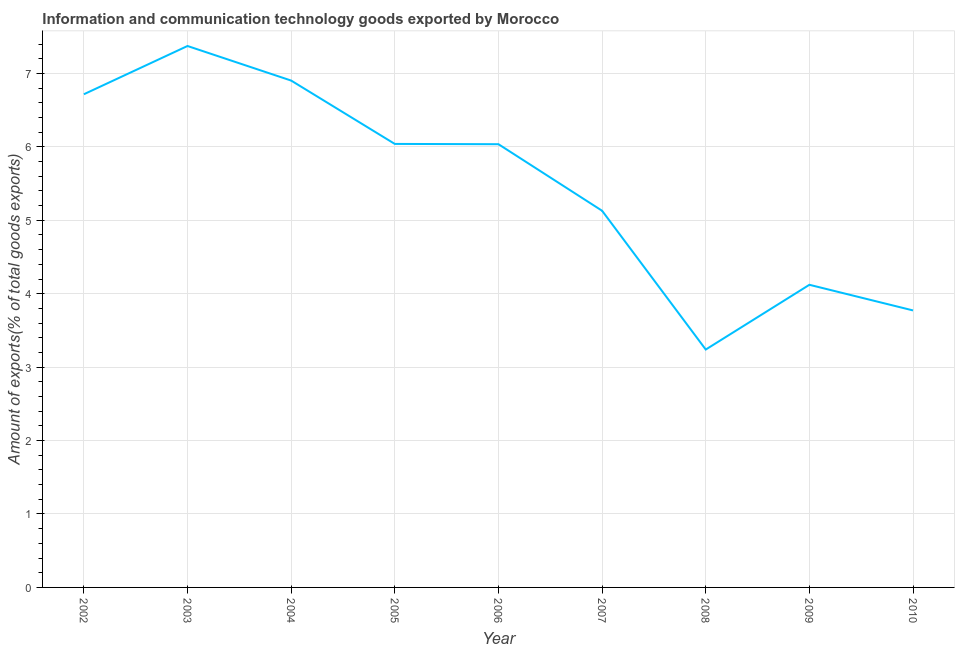What is the amount of ict goods exports in 2006?
Your answer should be compact. 6.04. Across all years, what is the maximum amount of ict goods exports?
Keep it short and to the point. 7.37. Across all years, what is the minimum amount of ict goods exports?
Give a very brief answer. 3.24. What is the sum of the amount of ict goods exports?
Make the answer very short. 49.33. What is the difference between the amount of ict goods exports in 2008 and 2010?
Ensure brevity in your answer.  -0.53. What is the average amount of ict goods exports per year?
Your answer should be very brief. 5.48. What is the median amount of ict goods exports?
Give a very brief answer. 6.04. Do a majority of the years between 2010 and 2006 (inclusive) have amount of ict goods exports greater than 1.6 %?
Your response must be concise. Yes. What is the ratio of the amount of ict goods exports in 2008 to that in 2009?
Your answer should be compact. 0.79. What is the difference between the highest and the second highest amount of ict goods exports?
Make the answer very short. 0.47. Is the sum of the amount of ict goods exports in 2002 and 2008 greater than the maximum amount of ict goods exports across all years?
Offer a terse response. Yes. What is the difference between the highest and the lowest amount of ict goods exports?
Make the answer very short. 4.13. In how many years, is the amount of ict goods exports greater than the average amount of ict goods exports taken over all years?
Keep it short and to the point. 5. Does the amount of ict goods exports monotonically increase over the years?
Offer a very short reply. No. How many years are there in the graph?
Keep it short and to the point. 9. What is the difference between two consecutive major ticks on the Y-axis?
Your response must be concise. 1. Are the values on the major ticks of Y-axis written in scientific E-notation?
Offer a very short reply. No. Does the graph contain grids?
Your answer should be very brief. Yes. What is the title of the graph?
Offer a terse response. Information and communication technology goods exported by Morocco. What is the label or title of the Y-axis?
Keep it short and to the point. Amount of exports(% of total goods exports). What is the Amount of exports(% of total goods exports) in 2002?
Your response must be concise. 6.72. What is the Amount of exports(% of total goods exports) of 2003?
Provide a short and direct response. 7.37. What is the Amount of exports(% of total goods exports) in 2004?
Keep it short and to the point. 6.9. What is the Amount of exports(% of total goods exports) in 2005?
Offer a very short reply. 6.04. What is the Amount of exports(% of total goods exports) of 2006?
Give a very brief answer. 6.04. What is the Amount of exports(% of total goods exports) of 2007?
Give a very brief answer. 5.13. What is the Amount of exports(% of total goods exports) in 2008?
Make the answer very short. 3.24. What is the Amount of exports(% of total goods exports) in 2009?
Provide a succinct answer. 4.12. What is the Amount of exports(% of total goods exports) of 2010?
Your response must be concise. 3.77. What is the difference between the Amount of exports(% of total goods exports) in 2002 and 2003?
Offer a very short reply. -0.66. What is the difference between the Amount of exports(% of total goods exports) in 2002 and 2004?
Your answer should be compact. -0.19. What is the difference between the Amount of exports(% of total goods exports) in 2002 and 2005?
Provide a succinct answer. 0.68. What is the difference between the Amount of exports(% of total goods exports) in 2002 and 2006?
Your answer should be compact. 0.68. What is the difference between the Amount of exports(% of total goods exports) in 2002 and 2007?
Offer a terse response. 1.59. What is the difference between the Amount of exports(% of total goods exports) in 2002 and 2008?
Your answer should be very brief. 3.48. What is the difference between the Amount of exports(% of total goods exports) in 2002 and 2009?
Give a very brief answer. 2.59. What is the difference between the Amount of exports(% of total goods exports) in 2002 and 2010?
Offer a terse response. 2.94. What is the difference between the Amount of exports(% of total goods exports) in 2003 and 2004?
Keep it short and to the point. 0.47. What is the difference between the Amount of exports(% of total goods exports) in 2003 and 2005?
Ensure brevity in your answer.  1.33. What is the difference between the Amount of exports(% of total goods exports) in 2003 and 2006?
Give a very brief answer. 1.34. What is the difference between the Amount of exports(% of total goods exports) in 2003 and 2007?
Keep it short and to the point. 2.24. What is the difference between the Amount of exports(% of total goods exports) in 2003 and 2008?
Offer a very short reply. 4.13. What is the difference between the Amount of exports(% of total goods exports) in 2003 and 2009?
Your answer should be compact. 3.25. What is the difference between the Amount of exports(% of total goods exports) in 2003 and 2010?
Provide a short and direct response. 3.6. What is the difference between the Amount of exports(% of total goods exports) in 2004 and 2005?
Keep it short and to the point. 0.86. What is the difference between the Amount of exports(% of total goods exports) in 2004 and 2006?
Keep it short and to the point. 0.87. What is the difference between the Amount of exports(% of total goods exports) in 2004 and 2007?
Your answer should be compact. 1.77. What is the difference between the Amount of exports(% of total goods exports) in 2004 and 2008?
Your answer should be very brief. 3.66. What is the difference between the Amount of exports(% of total goods exports) in 2004 and 2009?
Make the answer very short. 2.78. What is the difference between the Amount of exports(% of total goods exports) in 2004 and 2010?
Your answer should be very brief. 3.13. What is the difference between the Amount of exports(% of total goods exports) in 2005 and 2006?
Give a very brief answer. 0. What is the difference between the Amount of exports(% of total goods exports) in 2005 and 2007?
Offer a very short reply. 0.91. What is the difference between the Amount of exports(% of total goods exports) in 2005 and 2008?
Your response must be concise. 2.8. What is the difference between the Amount of exports(% of total goods exports) in 2005 and 2009?
Offer a very short reply. 1.92. What is the difference between the Amount of exports(% of total goods exports) in 2005 and 2010?
Offer a very short reply. 2.27. What is the difference between the Amount of exports(% of total goods exports) in 2006 and 2007?
Your answer should be very brief. 0.91. What is the difference between the Amount of exports(% of total goods exports) in 2006 and 2008?
Your answer should be very brief. 2.8. What is the difference between the Amount of exports(% of total goods exports) in 2006 and 2009?
Give a very brief answer. 1.91. What is the difference between the Amount of exports(% of total goods exports) in 2006 and 2010?
Provide a succinct answer. 2.26. What is the difference between the Amount of exports(% of total goods exports) in 2007 and 2008?
Your answer should be compact. 1.89. What is the difference between the Amount of exports(% of total goods exports) in 2007 and 2009?
Ensure brevity in your answer.  1.01. What is the difference between the Amount of exports(% of total goods exports) in 2007 and 2010?
Provide a succinct answer. 1.36. What is the difference between the Amount of exports(% of total goods exports) in 2008 and 2009?
Ensure brevity in your answer.  -0.88. What is the difference between the Amount of exports(% of total goods exports) in 2008 and 2010?
Your answer should be very brief. -0.53. What is the difference between the Amount of exports(% of total goods exports) in 2009 and 2010?
Provide a succinct answer. 0.35. What is the ratio of the Amount of exports(% of total goods exports) in 2002 to that in 2003?
Offer a very short reply. 0.91. What is the ratio of the Amount of exports(% of total goods exports) in 2002 to that in 2004?
Offer a terse response. 0.97. What is the ratio of the Amount of exports(% of total goods exports) in 2002 to that in 2005?
Offer a terse response. 1.11. What is the ratio of the Amount of exports(% of total goods exports) in 2002 to that in 2006?
Make the answer very short. 1.11. What is the ratio of the Amount of exports(% of total goods exports) in 2002 to that in 2007?
Your answer should be very brief. 1.31. What is the ratio of the Amount of exports(% of total goods exports) in 2002 to that in 2008?
Provide a short and direct response. 2.07. What is the ratio of the Amount of exports(% of total goods exports) in 2002 to that in 2009?
Your answer should be very brief. 1.63. What is the ratio of the Amount of exports(% of total goods exports) in 2002 to that in 2010?
Offer a terse response. 1.78. What is the ratio of the Amount of exports(% of total goods exports) in 2003 to that in 2004?
Your answer should be compact. 1.07. What is the ratio of the Amount of exports(% of total goods exports) in 2003 to that in 2005?
Make the answer very short. 1.22. What is the ratio of the Amount of exports(% of total goods exports) in 2003 to that in 2006?
Offer a terse response. 1.22. What is the ratio of the Amount of exports(% of total goods exports) in 2003 to that in 2007?
Offer a very short reply. 1.44. What is the ratio of the Amount of exports(% of total goods exports) in 2003 to that in 2008?
Offer a terse response. 2.28. What is the ratio of the Amount of exports(% of total goods exports) in 2003 to that in 2009?
Ensure brevity in your answer.  1.79. What is the ratio of the Amount of exports(% of total goods exports) in 2003 to that in 2010?
Offer a terse response. 1.96. What is the ratio of the Amount of exports(% of total goods exports) in 2004 to that in 2005?
Keep it short and to the point. 1.14. What is the ratio of the Amount of exports(% of total goods exports) in 2004 to that in 2006?
Your answer should be very brief. 1.14. What is the ratio of the Amount of exports(% of total goods exports) in 2004 to that in 2007?
Ensure brevity in your answer.  1.35. What is the ratio of the Amount of exports(% of total goods exports) in 2004 to that in 2008?
Offer a very short reply. 2.13. What is the ratio of the Amount of exports(% of total goods exports) in 2004 to that in 2009?
Your answer should be very brief. 1.68. What is the ratio of the Amount of exports(% of total goods exports) in 2004 to that in 2010?
Your response must be concise. 1.83. What is the ratio of the Amount of exports(% of total goods exports) in 2005 to that in 2006?
Provide a short and direct response. 1. What is the ratio of the Amount of exports(% of total goods exports) in 2005 to that in 2007?
Provide a succinct answer. 1.18. What is the ratio of the Amount of exports(% of total goods exports) in 2005 to that in 2008?
Provide a short and direct response. 1.86. What is the ratio of the Amount of exports(% of total goods exports) in 2005 to that in 2009?
Keep it short and to the point. 1.47. What is the ratio of the Amount of exports(% of total goods exports) in 2005 to that in 2010?
Your answer should be compact. 1.6. What is the ratio of the Amount of exports(% of total goods exports) in 2006 to that in 2007?
Your answer should be compact. 1.18. What is the ratio of the Amount of exports(% of total goods exports) in 2006 to that in 2008?
Your answer should be very brief. 1.86. What is the ratio of the Amount of exports(% of total goods exports) in 2006 to that in 2009?
Provide a short and direct response. 1.47. What is the ratio of the Amount of exports(% of total goods exports) in 2007 to that in 2008?
Keep it short and to the point. 1.58. What is the ratio of the Amount of exports(% of total goods exports) in 2007 to that in 2009?
Offer a very short reply. 1.25. What is the ratio of the Amount of exports(% of total goods exports) in 2007 to that in 2010?
Make the answer very short. 1.36. What is the ratio of the Amount of exports(% of total goods exports) in 2008 to that in 2009?
Ensure brevity in your answer.  0.79. What is the ratio of the Amount of exports(% of total goods exports) in 2008 to that in 2010?
Your answer should be very brief. 0.86. What is the ratio of the Amount of exports(% of total goods exports) in 2009 to that in 2010?
Offer a terse response. 1.09. 